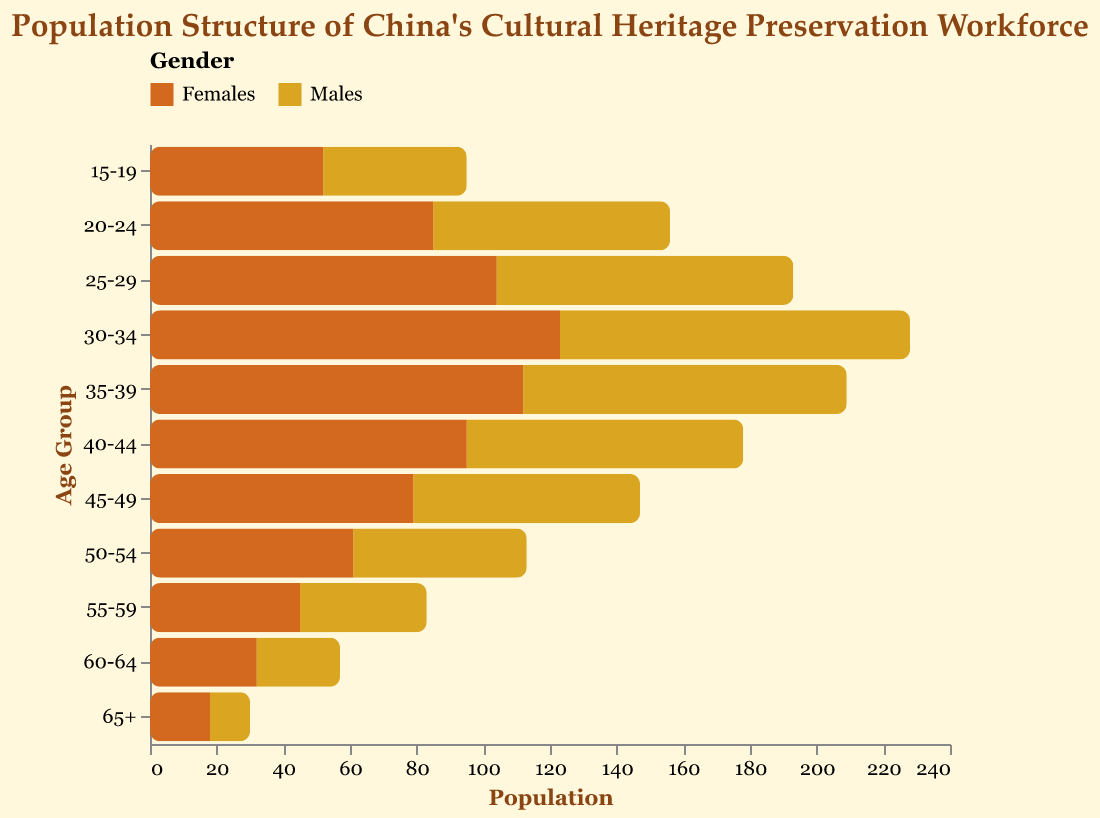What's the title of the figure? The title of the figure is displayed at the top and it is written in larger, bolder font compared to other texts in the figure.
Answer: Population Structure of China's Cultural Heritage Preservation Workforce What's the age group with the highest female population? Firstly, check each bar representing females in each age group and look for the longest one. The bar for the age group 30-34 is the longest among the female categories.
Answer: 30-34 In the age group 50-54, how many more females are there than males? For the age group 50-54, the bar representing males ends at -52, while the bar for females ends at 61. Calculate the difference, which is 61 - 52.
Answer: 9 What is the combined population of males and females in the age group 60-64? Add up the males (25) and females (32) populations in the age group 60-64. So, 25 + 32.
Answer: 57 Which age group has the closest male and female populations? For each age group, check the difference in lengths of male and female bars. The age group 55-59 has 38 males and 45 females, with a difference of 7, which is the smallest difference among all age groups.
Answer: 55-59 Are there more males or females in the age group 25-29? Compare the lengths of bars for males and females in the age group 25-29. The bar for females (104) is longer than that for males (89).
Answer: Females What is the total number of males across all age groups? Sum up the population numbers for males in each age group: 12 + 25 + 38 + 52 + 68 + 83 + 97 + 105 + 89 + 71 + 43.
Answer: 683 Which age group has the highest combined population? Add the male and female populations for each age group and find the maximum. The age group 30-34 has 105 males and 123 females, for a combined total of 228.
Answer: 30-34 How does the population of females in the age group 40-44 compare to that in the age group 35-39? Compare the lengths of the bars for females; 95 females for 40-44 and 112 for 35-39. It shows that the population decreases from 35-39 to 40-44.
Answer: Decreases What is the gender ratio (males to females) in the age group 20-24? Calculate the ratio by dividing the male population by the female population for the age group 20-24: 71 (males) / 85 (females). The ratio is approximately 0.84.
Answer: 0.84 